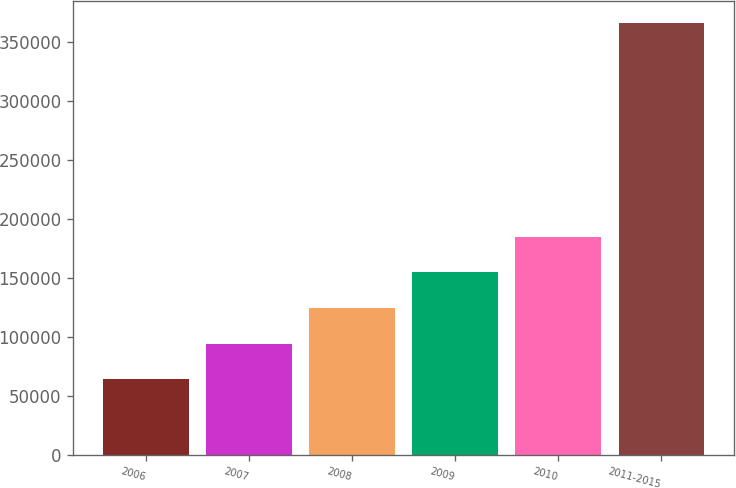Convert chart. <chart><loc_0><loc_0><loc_500><loc_500><bar_chart><fcel>2006<fcel>2007<fcel>2008<fcel>2009<fcel>2010<fcel>2011-2015<nl><fcel>63966<fcel>94214.8<fcel>124464<fcel>154712<fcel>184961<fcel>366454<nl></chart> 